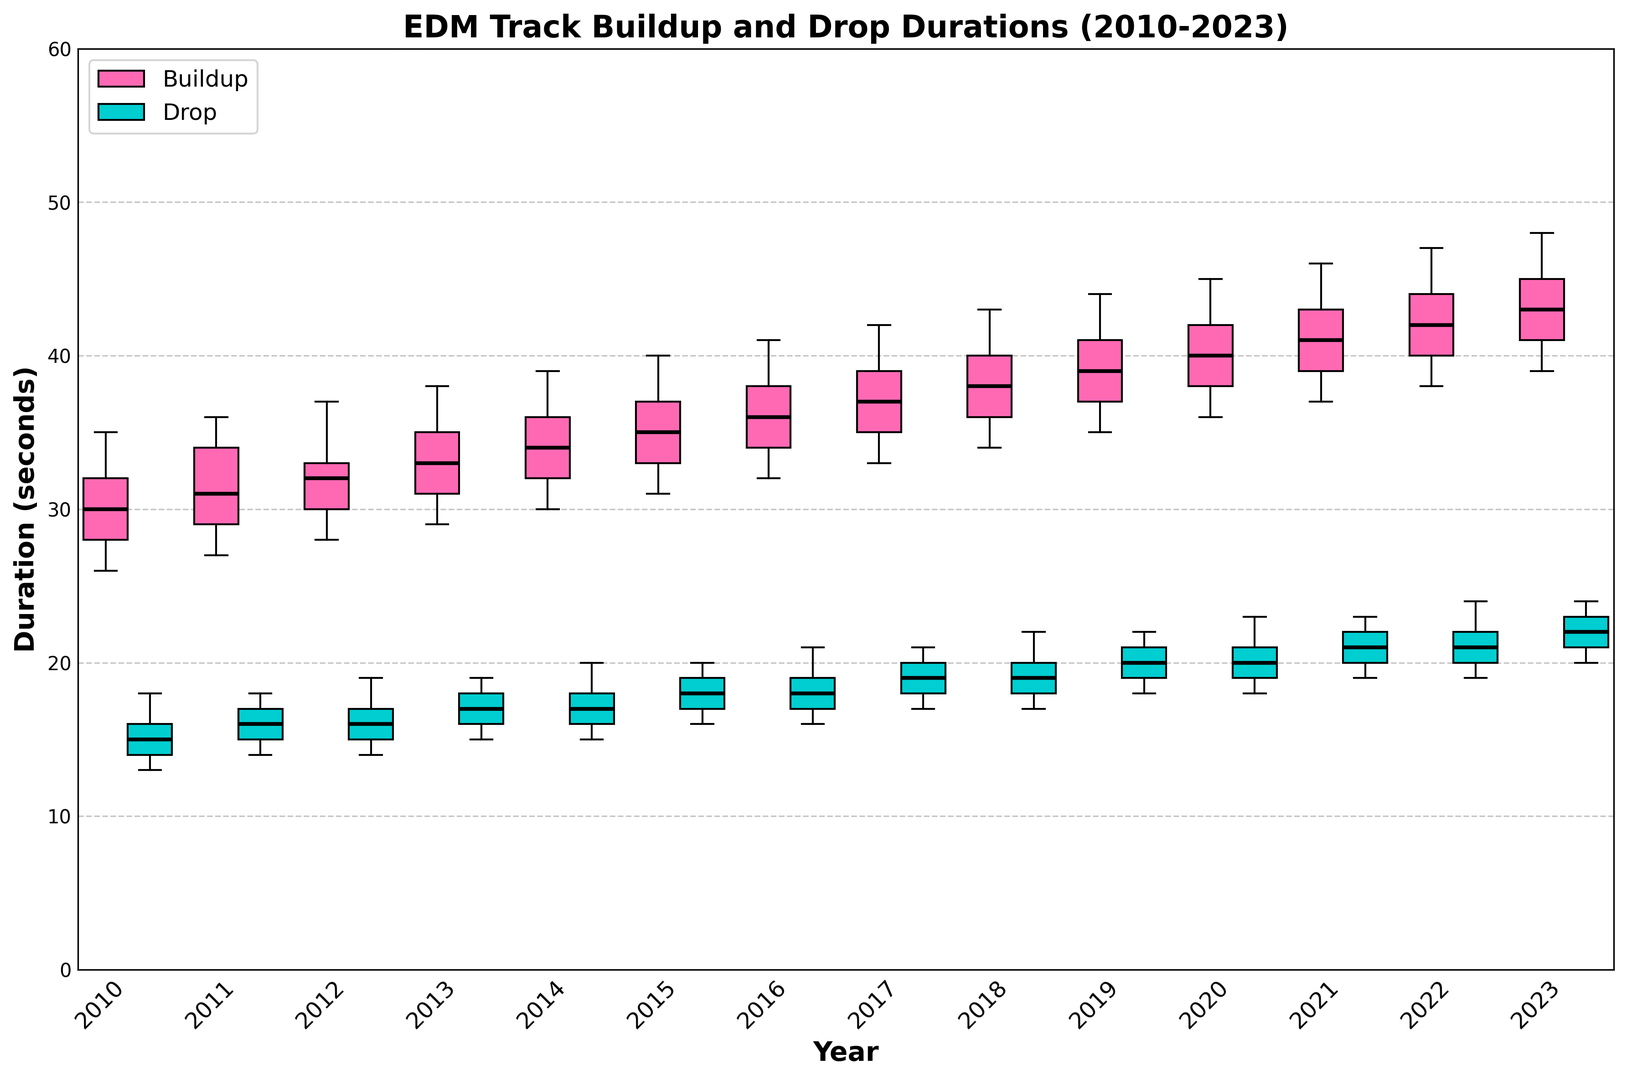Which year has the highest median buildup duration? The median buildup duration for each year is indicated by the horizontal line within each box for buildups. The year with the highest median buildup duration will have this line higher than the other years.
Answer: 2023 How does the median drop duration in 2015 compare to that in 2020? The horizontal lines within the boxes for drops indicate the medians. Compare the height of these lines between the years 2015 and 2020.
Answer: The median drop duration in 2015 is less than in 2020 What is the range of buildup durations in 2018 based on the box plot? The range can be found by subtracting the lower whisker value from the upper whisker value within the buildup box for the year 2018.
Answer: 43 - 34 = 9 Which year shows the greatest variability in drop durations? The variability is indicated by the length of the box and whiskers for the drop durations. Identify the year with the longest overall length of these elements.
Answer: 2018 Are there any years where the median buildup and drop durations are equal? Look at the position of the median lines within the buildup and drop boxes for each year to identify any overlaps.
Answer: No What can we say about the trend in buildup durations from 2010 to 2023? Observe the medians of the buildup durations across the years. If the median lines generally move upwards from 2010 to 2023, it indicates an increasing trend.
Answer: The trend shows an increase in buildup durations over the years Which year has the smallest interquartile range (IQR) for drop durations? The IQR is the length of the box, as it represents the range between the Q1 and Q3 quartiles. Find the year where the drop duration box is shortest.
Answer: 2010 Compared to 2012, how do the buildup durations in 2022 differ in terms of the median value? Compare the height of the median lines within the buildup boxes for 2012 and 2022.
Answer: The median buildup in 2022 is greater than in 2012 In which year is the median drop duration closest to the median buildup duration for the same year? Compare the positions of the median lines for both buildup and drop durations within the same year. Look for the closest alignment.
Answer: 2010 Is there any year where the median drop duration is higher than the median buildup duration? Determine if any year's drop duration median line is visually above the buildup duration median line for the same year.
Answer: No 